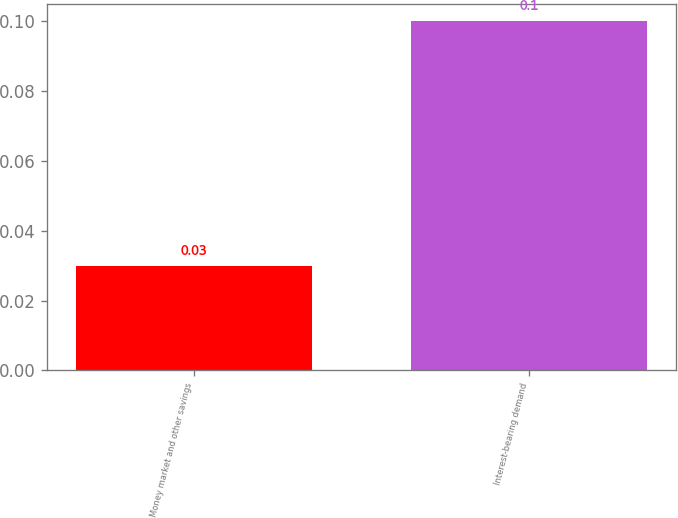<chart> <loc_0><loc_0><loc_500><loc_500><bar_chart><fcel>Money market and other savings<fcel>Interest-bearing demand<nl><fcel>0.03<fcel>0.1<nl></chart> 